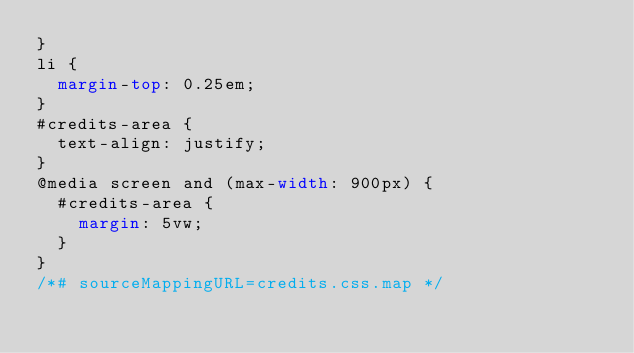Convert code to text. <code><loc_0><loc_0><loc_500><loc_500><_CSS_>}
li {
  margin-top: 0.25em;
}
#credits-area {
  text-align: justify;
}
@media screen and (max-width: 900px) {
  #credits-area {
    margin: 5vw;
  }
}
/*# sourceMappingURL=credits.css.map */</code> 